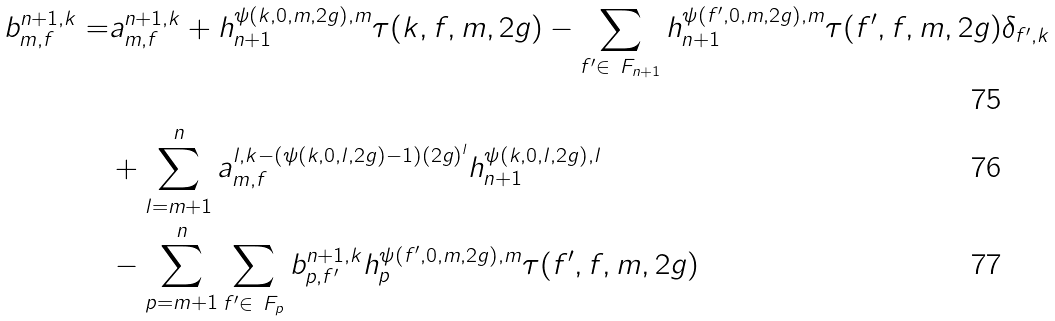Convert formula to latex. <formula><loc_0><loc_0><loc_500><loc_500>b _ { m , f } ^ { n + 1 , k } = & a _ { m , f } ^ { n + 1 , k } + h ^ { \psi ( k , 0 , m , 2 g ) , m } _ { n + 1 } \tau ( k , f , m , 2 g ) - \sum _ { f ^ { \prime } \in \ F _ { n + 1 } } h ^ { \psi ( f ^ { \prime } , 0 , m , 2 g ) , m } _ { n + 1 } \tau ( f ^ { \prime } , f , m , 2 g ) \delta _ { f ^ { \prime } , k } \\ & + \sum _ { l = m + 1 } ^ { n } a ^ { l , k - ( \psi ( k , 0 , l , 2 g ) - 1 ) ( 2 g ) ^ { l } } _ { m , f } h ^ { \psi ( k , 0 , l , 2 g ) , l } _ { n + 1 } \\ & - \sum _ { p = m + 1 } ^ { n } \sum _ { f ^ { \prime } \in \ F _ { p } } b _ { p , f ^ { \prime } } ^ { n + 1 , k } h ^ { \psi ( f ^ { \prime } , 0 , m , 2 g ) , m } _ { p } \tau ( f ^ { \prime } , f , m , 2 g )</formula> 